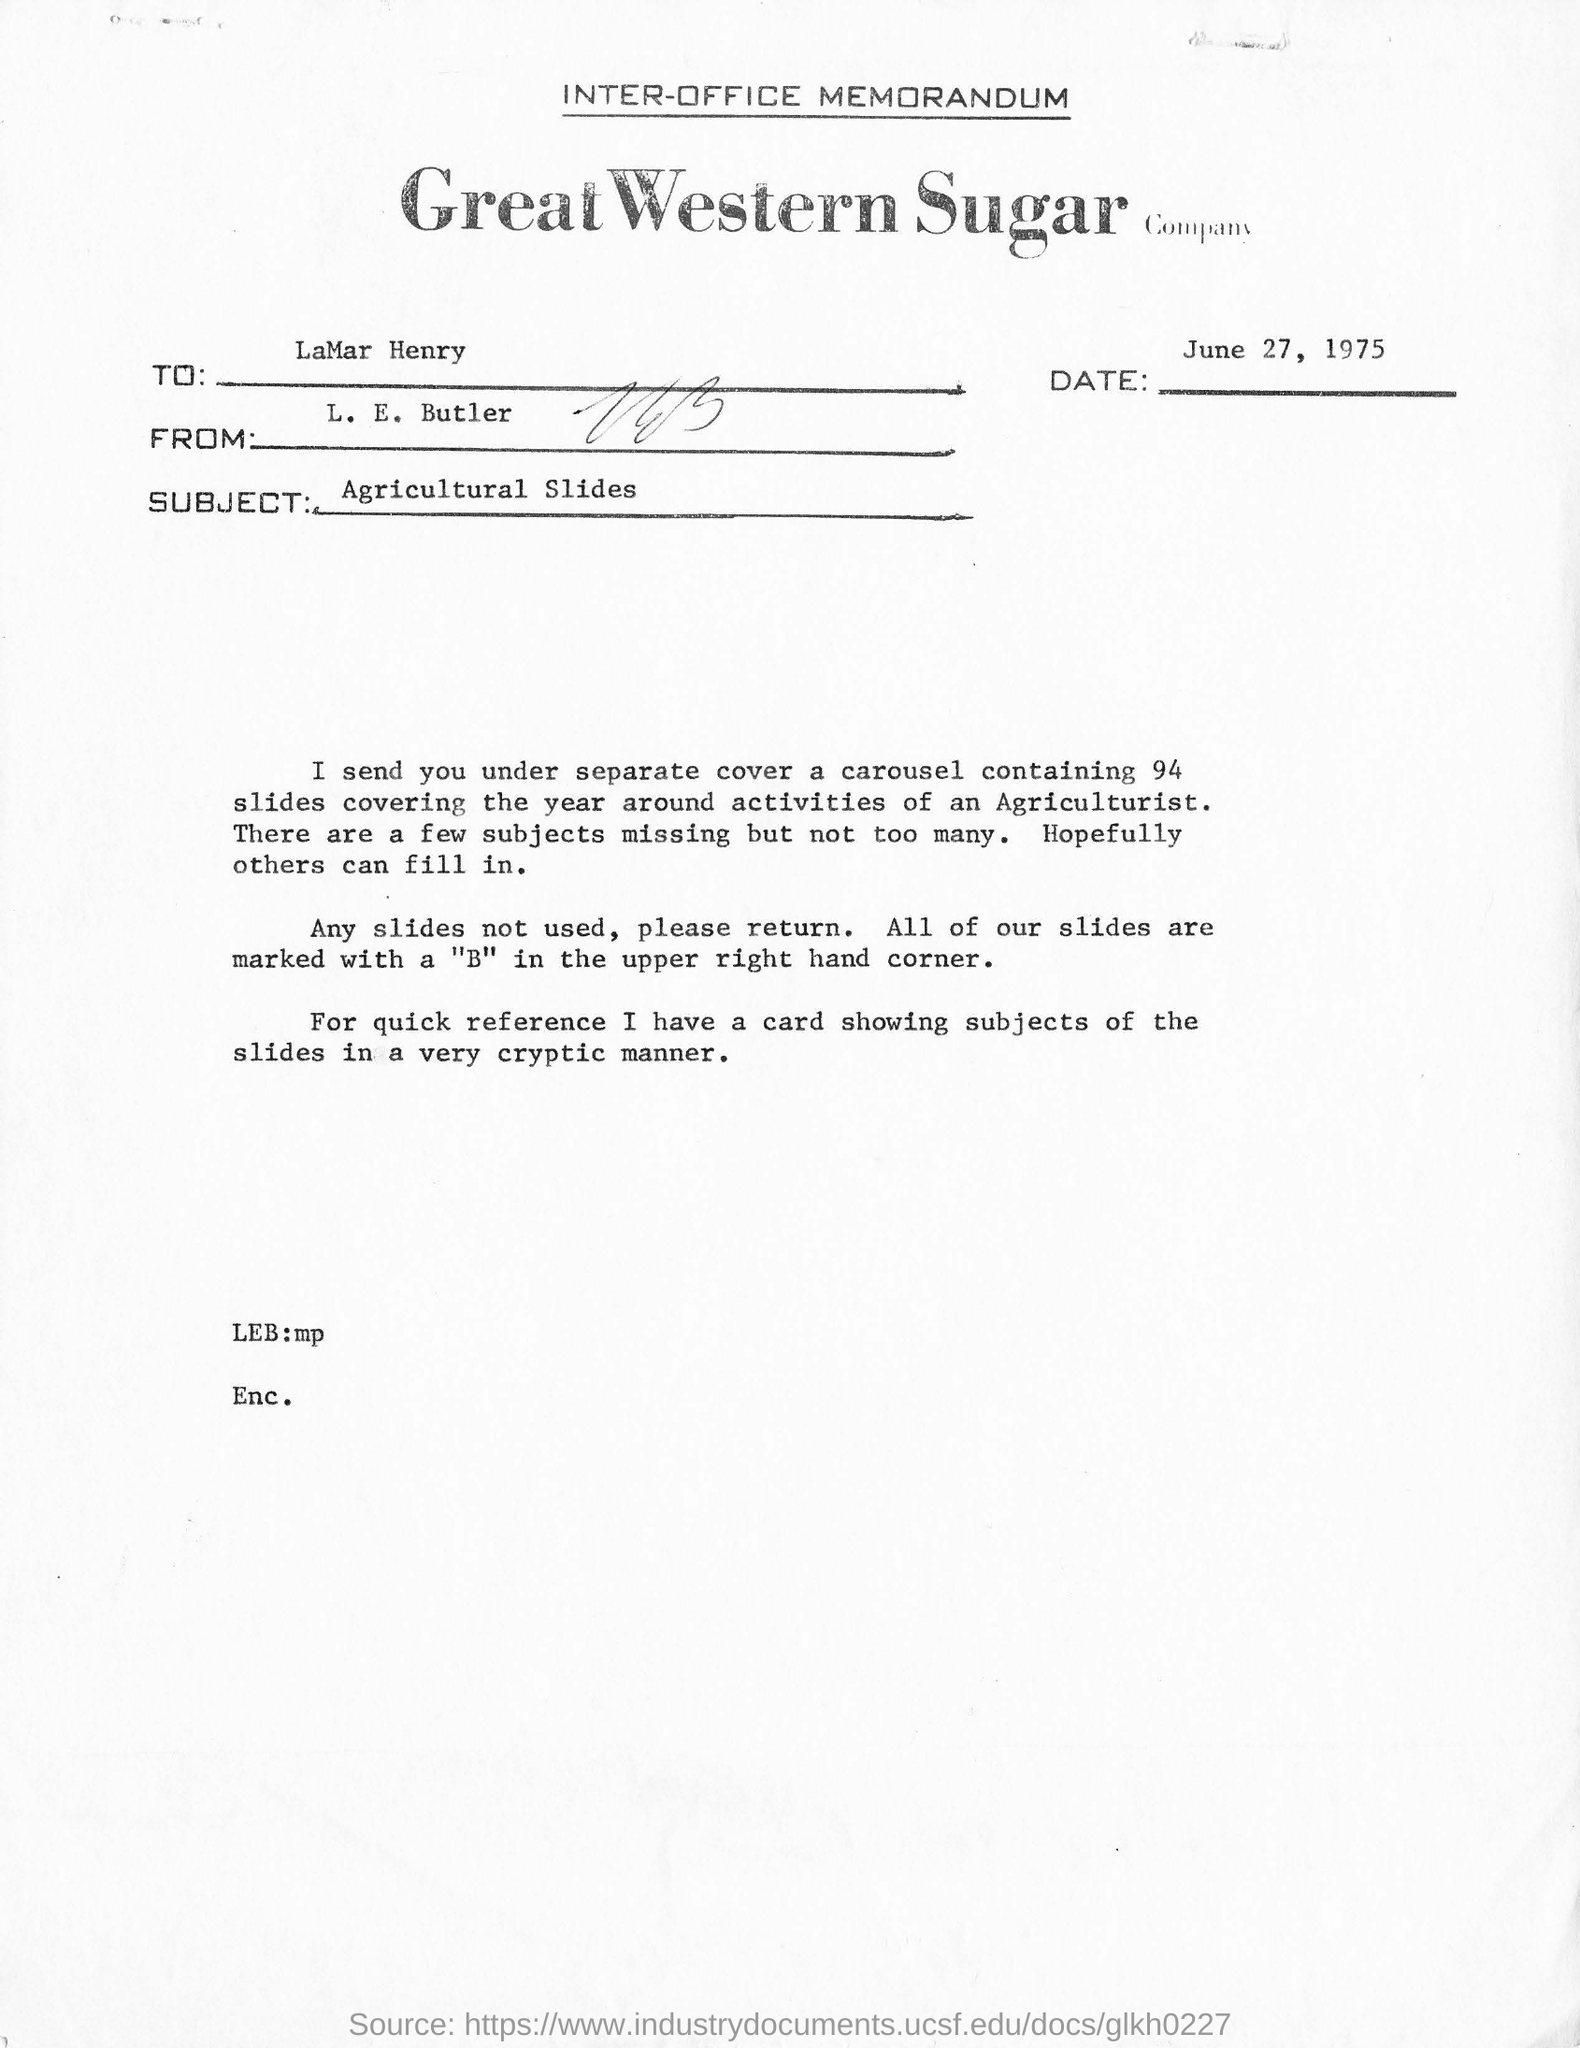What is written in top of the Document ?
Your response must be concise. INTER-OFFICE MEMORANDUM. What is the Company Name ?
Make the answer very short. GREAT WESTERN SUGAR COMPANY. What is the date mentioned in the document ?
Provide a succinct answer. JUNE 27, 1975. Who sent this ?
Provide a succinct answer. L. E. Butler. Who is the recipient
Offer a terse response. LaMar Henry. What is the Subject ?
Offer a terse response. AGRICULTURAL SLIDES. How many slides covering the year around activities of an Agriculturist ?
Your response must be concise. 94. 